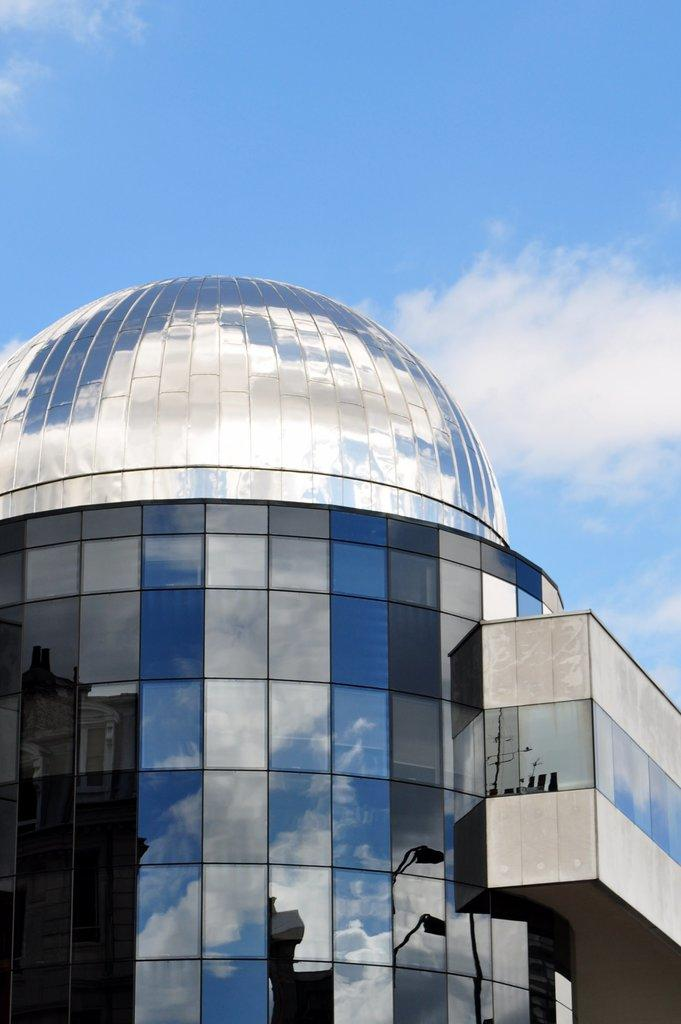What type of building is in the image? There is a glass building in the image. What can be seen in the background of the image? The sky is visible in the image. What is the condition of the sky in the image? The sky is cloudy in the image. What type of silverware is being used by the person wearing a sweater in the image? There is no person wearing a sweater or using silverware in the image; it only features a glass building and a cloudy sky. 